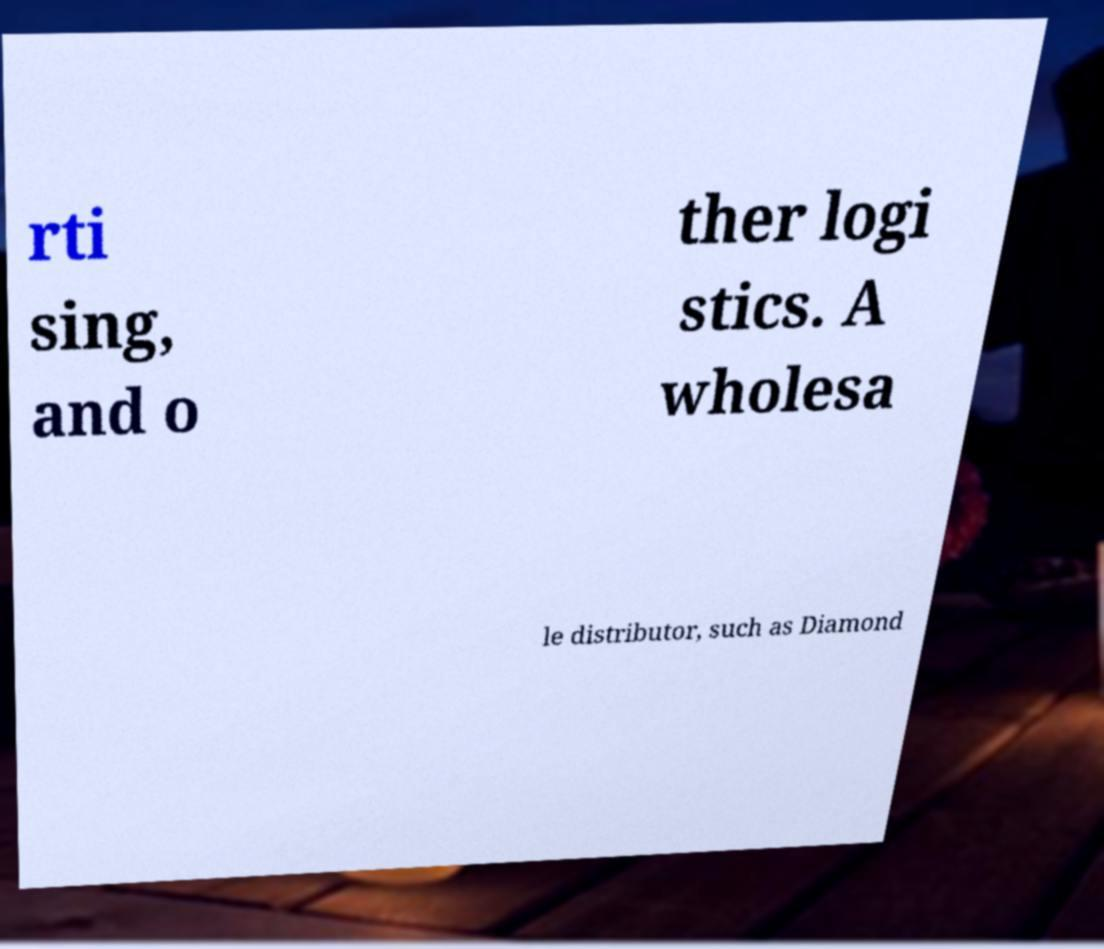For documentation purposes, I need the text within this image transcribed. Could you provide that? rti sing, and o ther logi stics. A wholesa le distributor, such as Diamond 